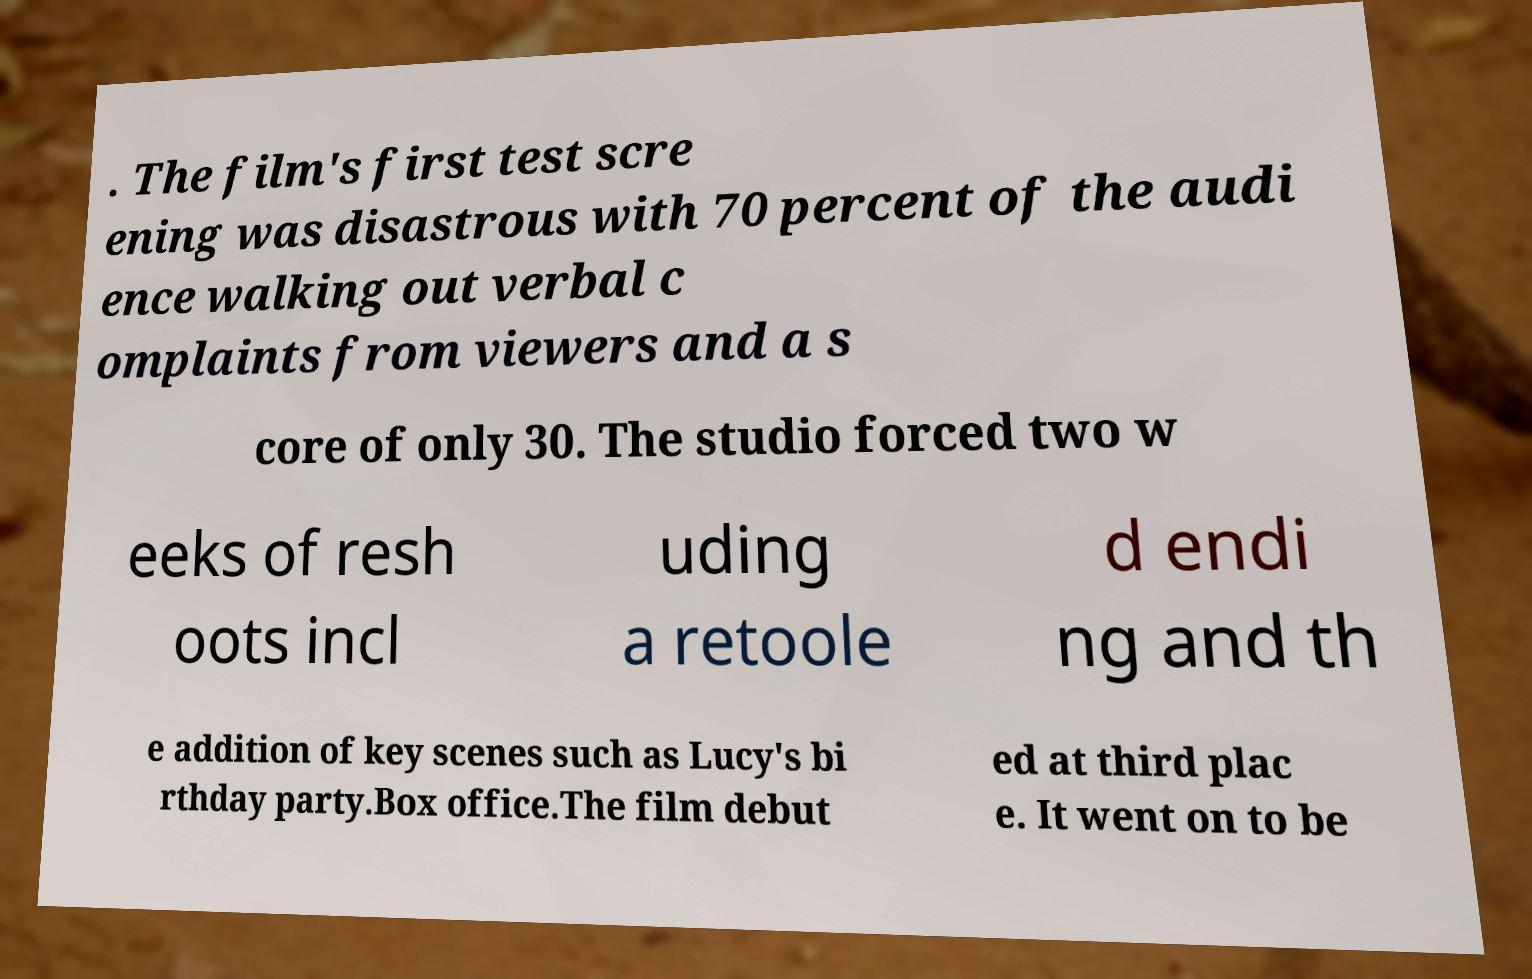Could you assist in decoding the text presented in this image and type it out clearly? . The film's first test scre ening was disastrous with 70 percent of the audi ence walking out verbal c omplaints from viewers and a s core of only 30. The studio forced two w eeks of resh oots incl uding a retoole d endi ng and th e addition of key scenes such as Lucy's bi rthday party.Box office.The film debut ed at third plac e. It went on to be 